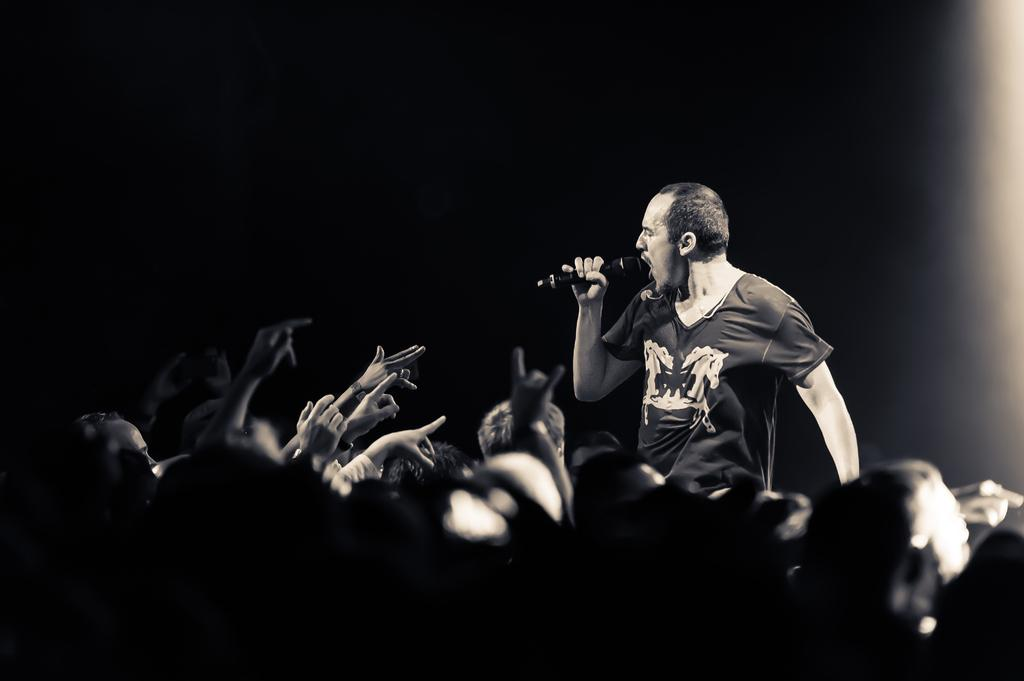What is the person in the image holding? The person in the image is holding a microphone. Can you describe the other people in the image? There are a few persons at the bottom of the image. What type of lamp is being used by the worm in the image? There is no lamp or worm present in the image. 